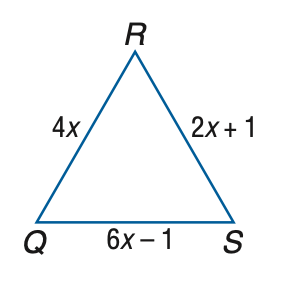Answer the mathemtical geometry problem and directly provide the correct option letter.
Question: Find Q R if \triangle Q R S is an equilateral triangle.
Choices: A: 0.5 B: 1 C: 1.5 D: 2 D 